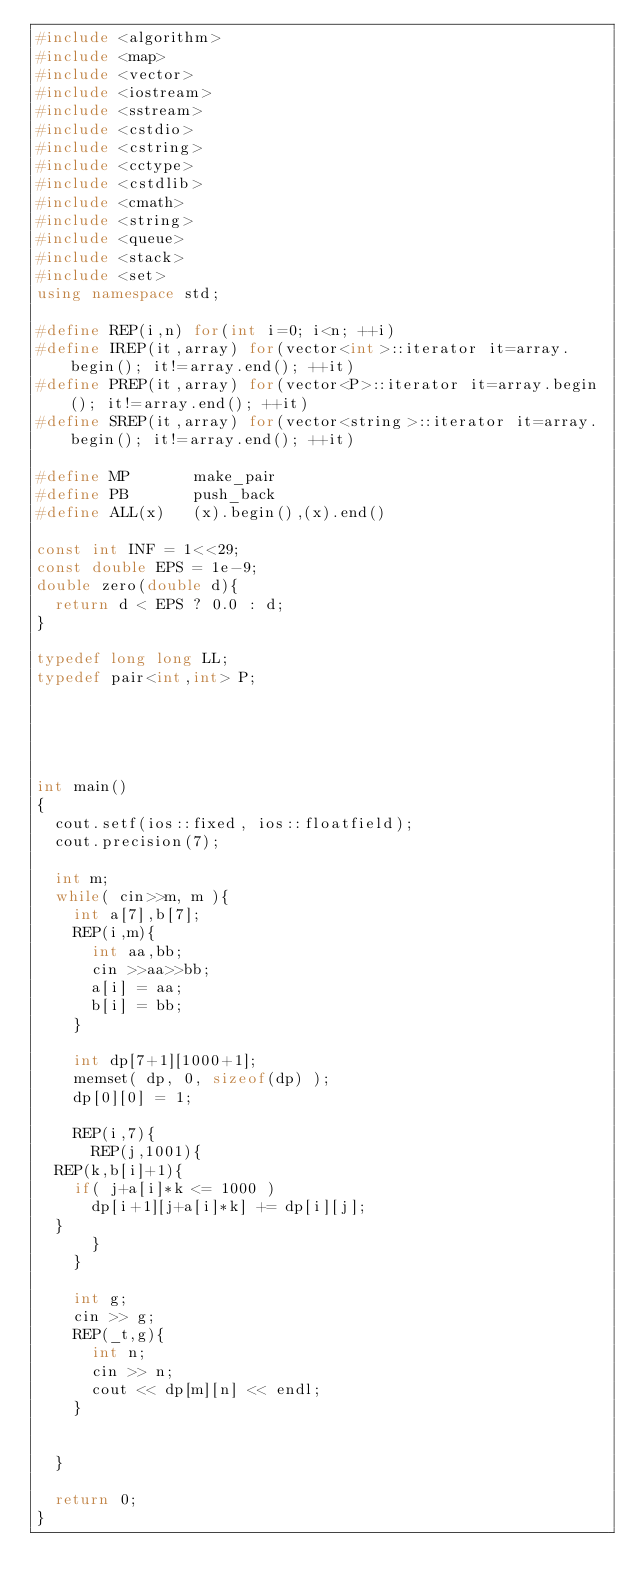<code> <loc_0><loc_0><loc_500><loc_500><_C++_>#include <algorithm>
#include <map>
#include <vector>
#include <iostream>
#include <sstream>
#include <cstdio>
#include <cstring>
#include <cctype>
#include <cstdlib>
#include <cmath>
#include <string>
#include <queue>
#include <stack>
#include <set>
using namespace std;

#define REP(i,n) for(int i=0; i<n; ++i)
#define IREP(it,array) for(vector<int>::iterator it=array.begin(); it!=array.end(); ++it)
#define PREP(it,array) for(vector<P>::iterator it=array.begin(); it!=array.end(); ++it)
#define SREP(it,array) for(vector<string>::iterator it=array.begin(); it!=array.end(); ++it)

#define MP       make_pair
#define PB       push_back
#define ALL(x)   (x).begin(),(x).end()

const int INF = 1<<29;
const double EPS = 1e-9;
double zero(double d){
  return d < EPS ? 0.0 : d;
}

typedef long long LL;
typedef pair<int,int> P;





int main()
{
  cout.setf(ios::fixed, ios::floatfield);
  cout.precision(7);

  int m;
  while( cin>>m, m ){
    int a[7],b[7];
    REP(i,m){
      int aa,bb;
      cin >>aa>>bb;
      a[i] = aa;
      b[i] = bb;
    }

    int dp[7+1][1000+1];
    memset( dp, 0, sizeof(dp) );
    dp[0][0] = 1;

    REP(i,7){
      REP(j,1001){
	REP(k,b[i]+1){
	  if( j+a[i]*k <= 1000 )
	    dp[i+1][j+a[i]*k] += dp[i][j];
	}
      }
    }

    int g;
    cin >> g;
    REP(_t,g){
      int n;
      cin >> n;
      cout << dp[m][n] << endl;
    }


  }

  return 0;
}</code> 